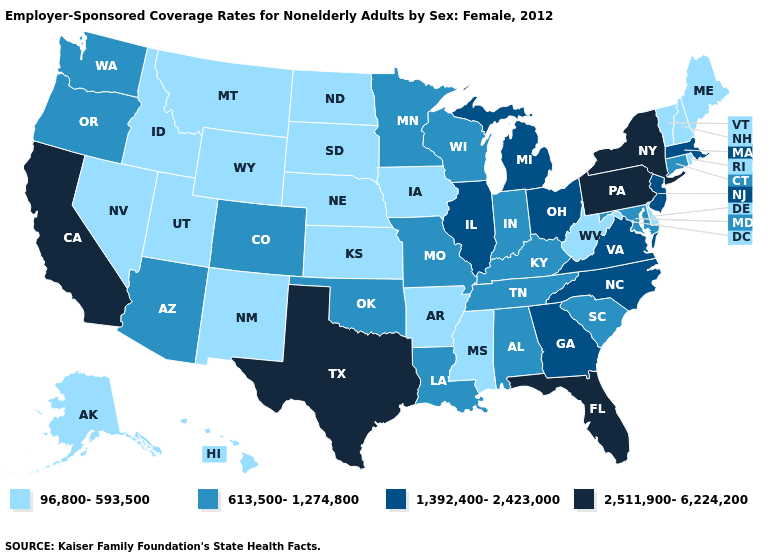Among the states that border Wyoming , does Colorado have the lowest value?
Answer briefly. No. Does Illinois have the highest value in the MidWest?
Short answer required. Yes. What is the value of Hawaii?
Be succinct. 96,800-593,500. Does Oregon have the lowest value in the USA?
Concise answer only. No. Does Tennessee have the lowest value in the USA?
Quick response, please. No. What is the value of New Hampshire?
Give a very brief answer. 96,800-593,500. Does Alabama have a higher value than Mississippi?
Quick response, please. Yes. Which states have the lowest value in the USA?
Quick response, please. Alaska, Arkansas, Delaware, Hawaii, Idaho, Iowa, Kansas, Maine, Mississippi, Montana, Nebraska, Nevada, New Hampshire, New Mexico, North Dakota, Rhode Island, South Dakota, Utah, Vermont, West Virginia, Wyoming. What is the value of Washington?
Answer briefly. 613,500-1,274,800. Does California have the highest value in the USA?
Give a very brief answer. Yes. What is the lowest value in the West?
Answer briefly. 96,800-593,500. Which states have the lowest value in the USA?
Be succinct. Alaska, Arkansas, Delaware, Hawaii, Idaho, Iowa, Kansas, Maine, Mississippi, Montana, Nebraska, Nevada, New Hampshire, New Mexico, North Dakota, Rhode Island, South Dakota, Utah, Vermont, West Virginia, Wyoming. Does South Dakota have the lowest value in the USA?
Keep it brief. Yes. What is the value of Alaska?
Answer briefly. 96,800-593,500. What is the highest value in states that border Maryland?
Give a very brief answer. 2,511,900-6,224,200. 